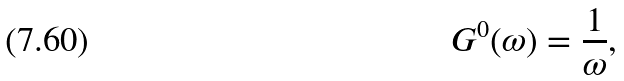Convert formula to latex. <formula><loc_0><loc_0><loc_500><loc_500>G ^ { 0 } ( \omega ) = \frac { 1 } { \omega } ,</formula> 